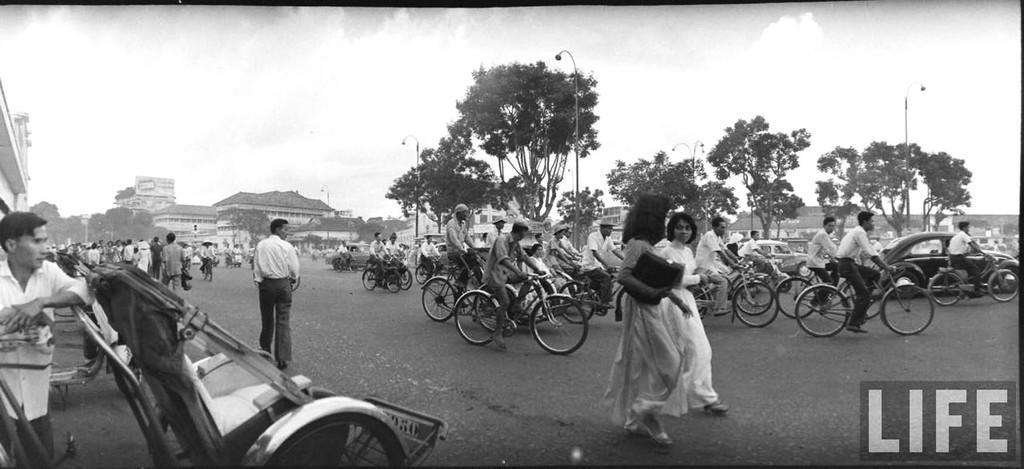How would you summarize this image in a sentence or two? This picture is clicked outside the city where the persons are standing, walking, and riding bicycles, and cars. In the background there are some trees, sky and cloud, there are buildings in the background. 